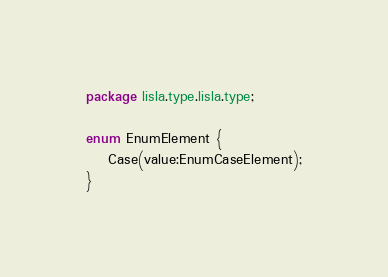<code> <loc_0><loc_0><loc_500><loc_500><_Haxe_>package lisla.type.lisla.type;

enum EnumElement {
    Case(value:EnumCaseElement);
}</code> 